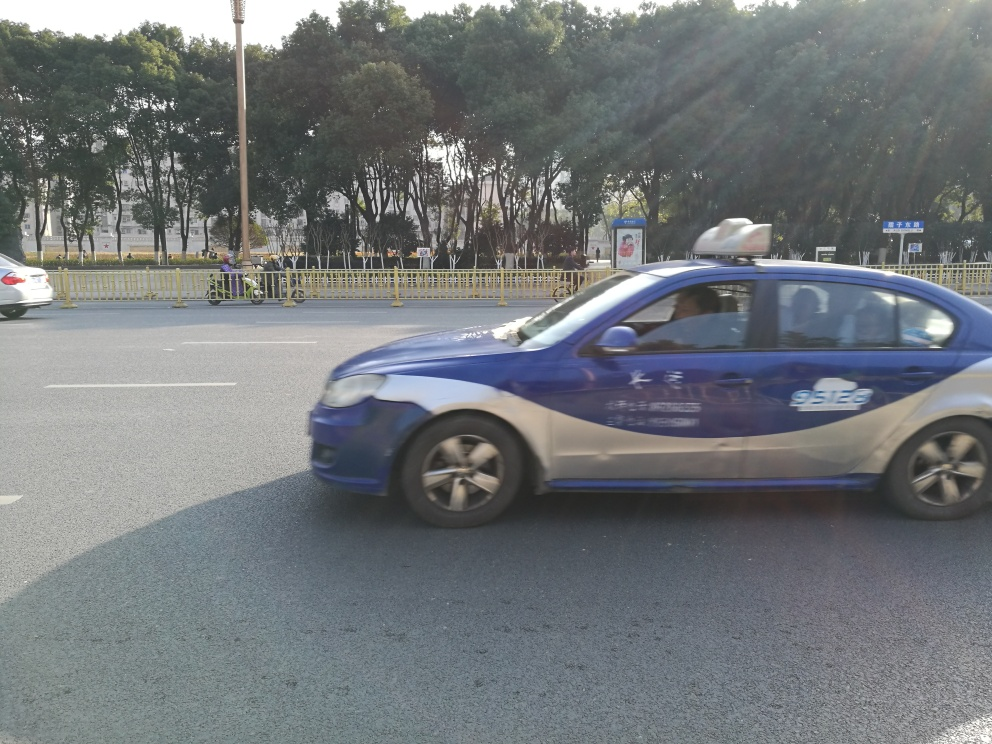Can you tell me what time of day this photo was taken? The photo seems to have been taken during the day, as indicated by the shadows on the ground suggesting sunlight and the brightness of the sky. 